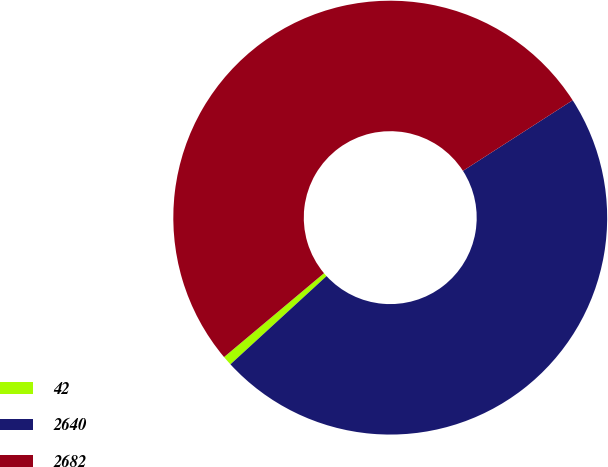<chart> <loc_0><loc_0><loc_500><loc_500><pie_chart><fcel>42<fcel>2640<fcel>2682<nl><fcel>0.71%<fcel>47.28%<fcel>52.01%<nl></chart> 